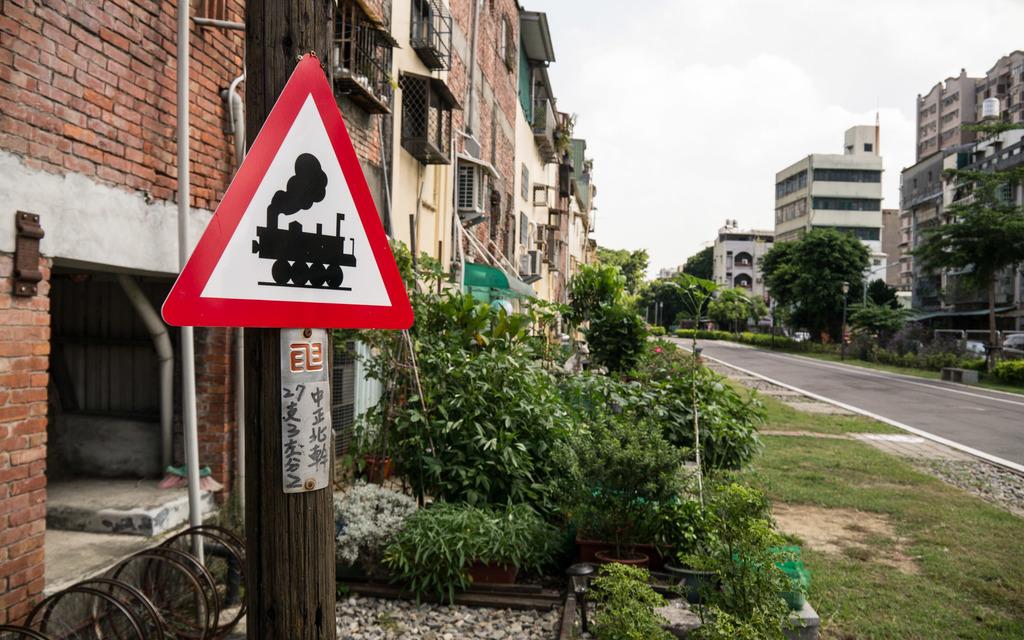Text is in foreign language?
Your answer should be very brief. Yes. 